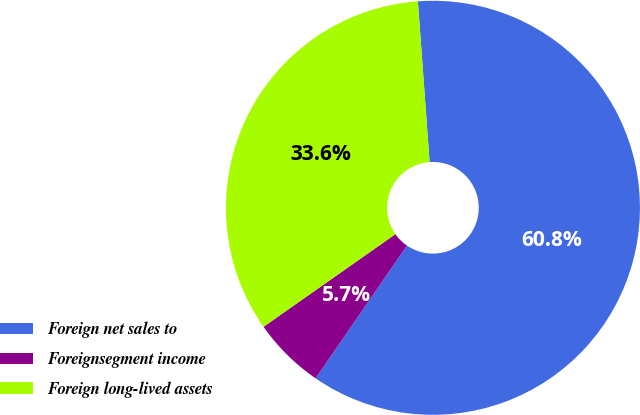<chart> <loc_0><loc_0><loc_500><loc_500><pie_chart><fcel>Foreign net sales to<fcel>Foreignsegment income<fcel>Foreign long-lived assets<nl><fcel>60.75%<fcel>5.66%<fcel>33.59%<nl></chart> 